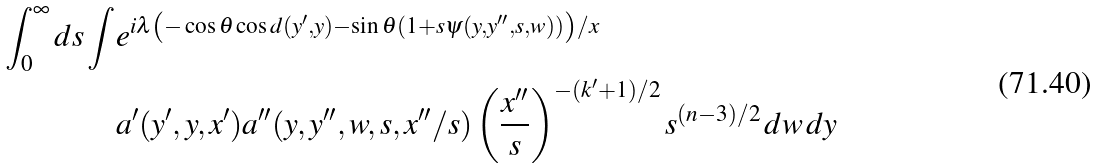<formula> <loc_0><loc_0><loc_500><loc_500>\int _ { 0 } ^ { \infty } d s \int & e ^ { i \lambda \left ( - \cos \theta \cos d ( y ^ { \prime } , y ) - \sin \theta ( 1 + s \psi ( y , y ^ { \prime \prime } , s , w ) ) \right ) / x } \\ & a ^ { \prime } ( y ^ { \prime } , y , x ^ { \prime } ) a ^ { \prime \prime } ( y , y ^ { \prime \prime } , w , s , x ^ { \prime \prime } / s ) \left ( \frac { x ^ { \prime \prime } } { s } \right ) ^ { - ( k ^ { \prime } + 1 ) / 2 } s ^ { ( n - 3 ) / 2 } \, d w \, d y</formula> 